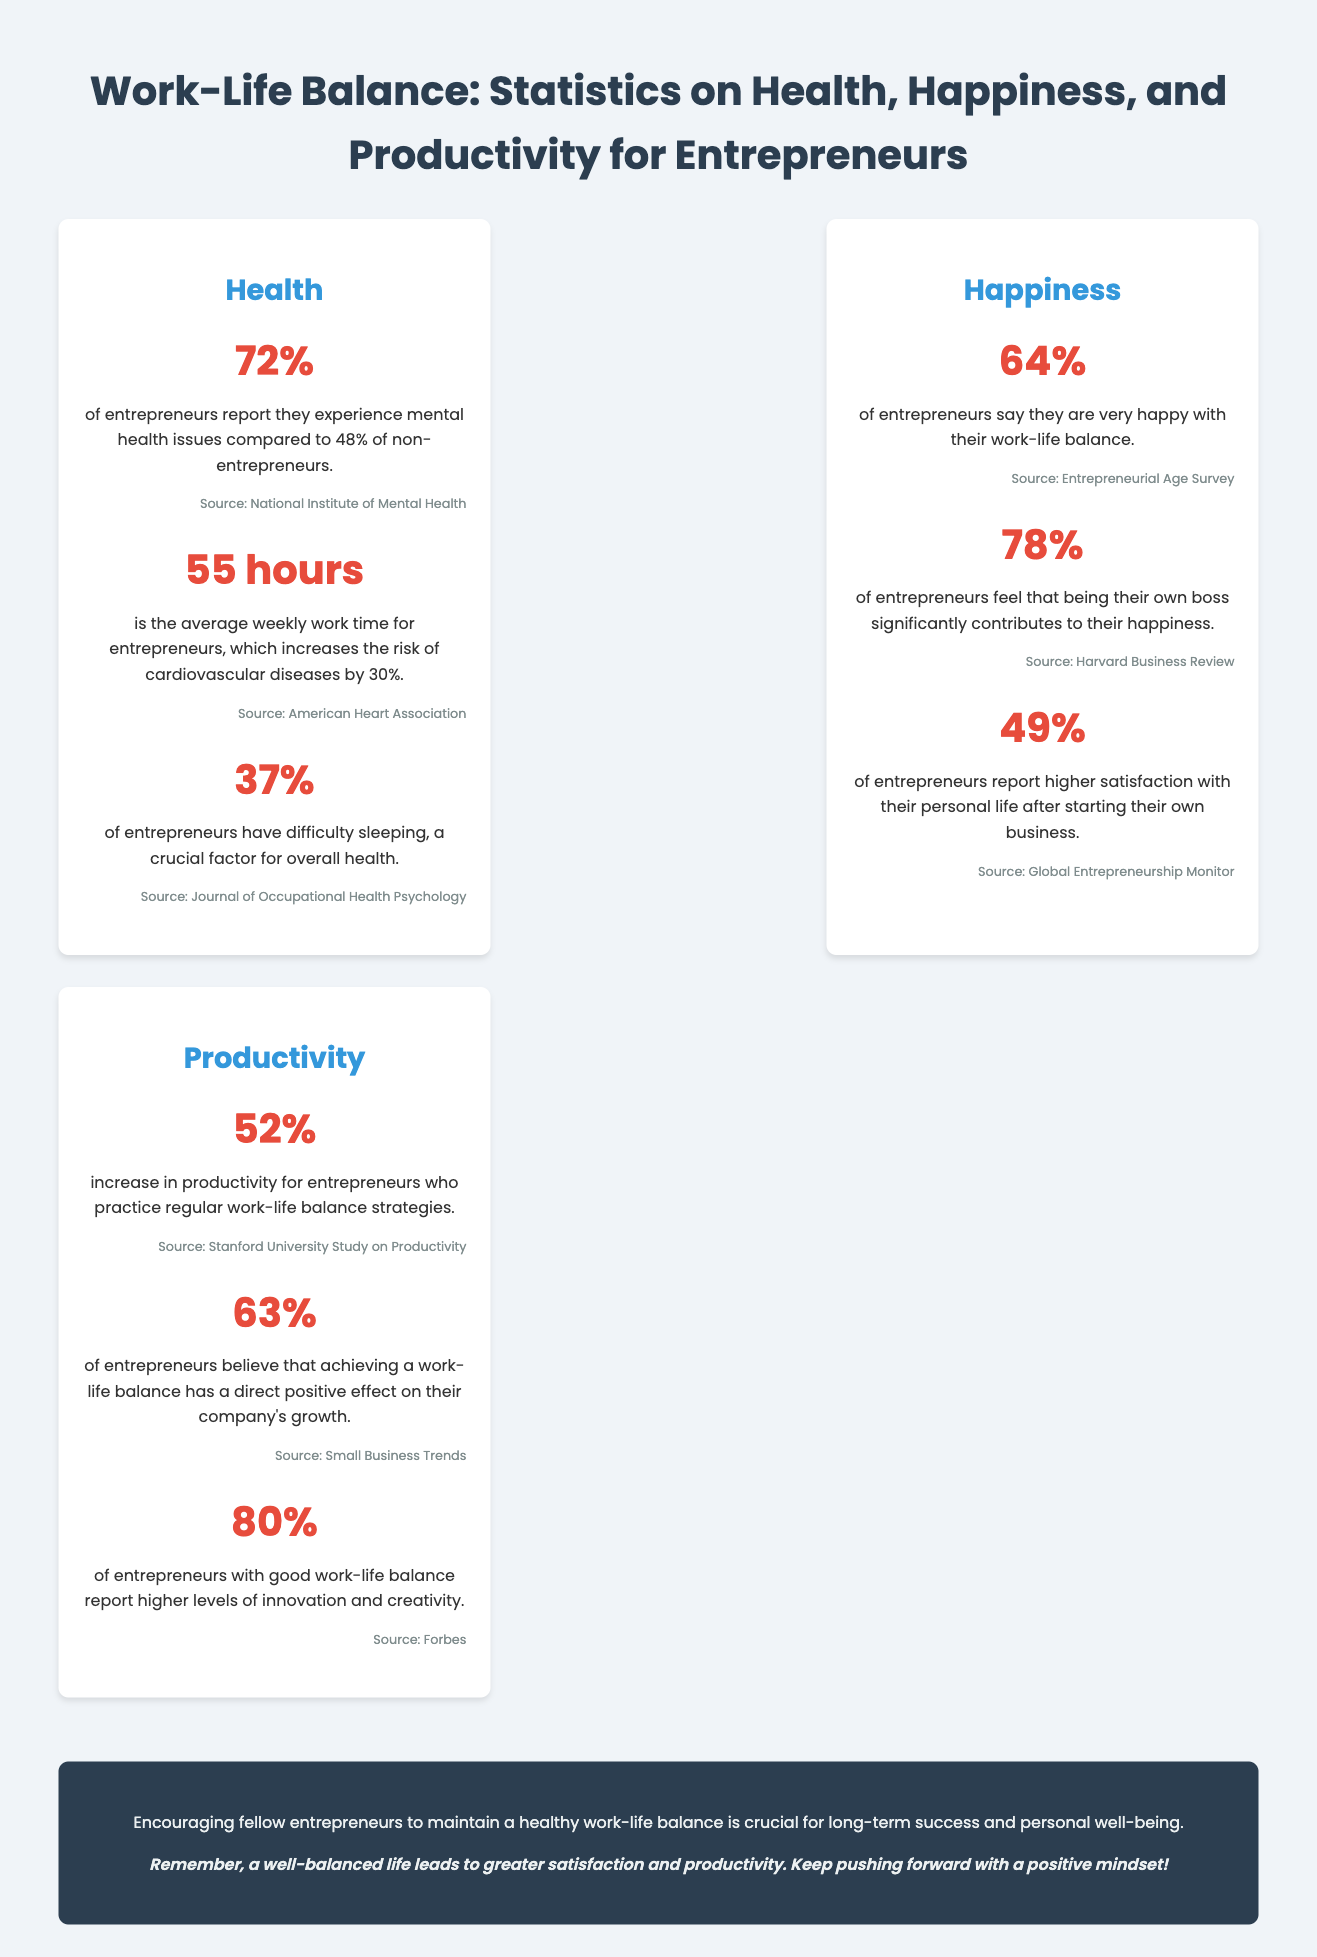what percentage of entrepreneurs report mental health issues? The document states that 72% of entrepreneurs report they experience mental health issues.
Answer: 72% how many hours is the average weekly work time for entrepreneurs? According to the document, the average weekly work time for entrepreneurs is 55 hours.
Answer: 55 hours what is the happiness percentage of entrepreneurs regarding their work-life balance? The document indicates that 64% of entrepreneurs say they are very happy with their work-life balance.
Answer: 64% what is the reported increase in productivity for entrepreneurs practicing work-life balance strategies? The document mentions a 52% increase in productivity for entrepreneurs who practice regular work-life balance strategies.
Answer: 52% how does being their own boss contribute to entrepreneurs' happiness? The statistics show that 78% of entrepreneurs feel that being their own boss significantly contributes to their happiness.
Answer: 78% what effect does work-life balance have on company growth, according to entrepreneurs? According to the document, 63% of entrepreneurs believe that achieving a work-life balance has a direct positive effect on their company's growth.
Answer: 63% what percentage of entrepreneurs with a good work-life balance report higher levels of innovation? The document states that 80% of entrepreneurs with a good work-life balance report higher levels of innovation and creativity.
Answer: 80% what is a crucial factor for overall health mentioned for entrepreneurs? The document highlights that 37% of entrepreneurs have difficulty sleeping, which is a crucial factor for overall health.
Answer: difficulty sleeping what is the source of the statistic regarding entrepreneurs experiencing mental health issues? The document cites the National Institute of Mental Health as the source for the statistic on mental health issues.
Answer: National Institute of Mental Health 